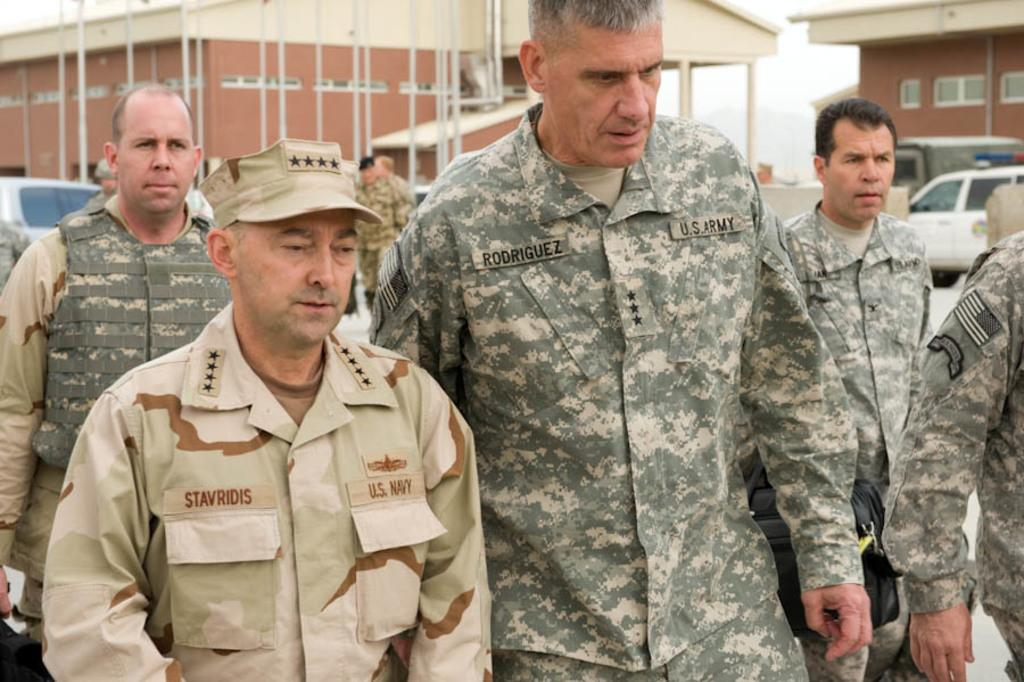What is the main subject of the image? The main subject of the image is a group of soldiers. What are the soldiers doing in the image? The soldiers are walking on the ground in the image. What type of buildings can be seen in the background? There are two quarters visible in the image. What else can be seen in the image besides the soldiers and quarters? Vehicles are parked in front of the quarters. What type of memory does the mother have in the image? There is no mother or memory present in the image; it features a group of soldiers walking on the ground with quarters and parked vehicles in the background. What scale is used to measure the soldiers' height in the image? There is no scale present in the image to measure the soldiers' height. 